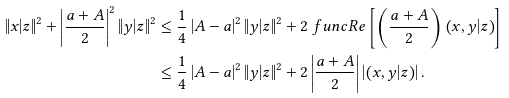Convert formula to latex. <formula><loc_0><loc_0><loc_500><loc_500>\left \| x | z \right \| ^ { 2 } + \left | \frac { a + A } { 2 } \right | ^ { 2 } \left \| y | z \right \| ^ { 2 } & \leq \frac { 1 } { 4 } \left | A - a \right | ^ { 2 } \left \| y | z \right \| ^ { 2 } + 2 \ f u n c { R e } \left [ \left ( \frac { a + A } { 2 } \right ) \left ( x , y | z \right ) \right ] \\ & \leq \frac { 1 } { 4 } \left | A - a \right | ^ { 2 } \left \| y | z \right \| ^ { 2 } + 2 \left | \frac { a + A } { 2 } \right | \left | \left ( x , y | z \right ) \right | .</formula> 